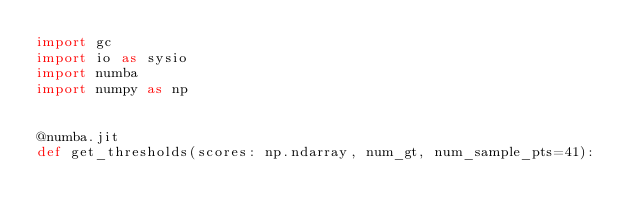Convert code to text. <code><loc_0><loc_0><loc_500><loc_500><_Python_>import gc
import io as sysio
import numba
import numpy as np


@numba.jit
def get_thresholds(scores: np.ndarray, num_gt, num_sample_pts=41):</code> 